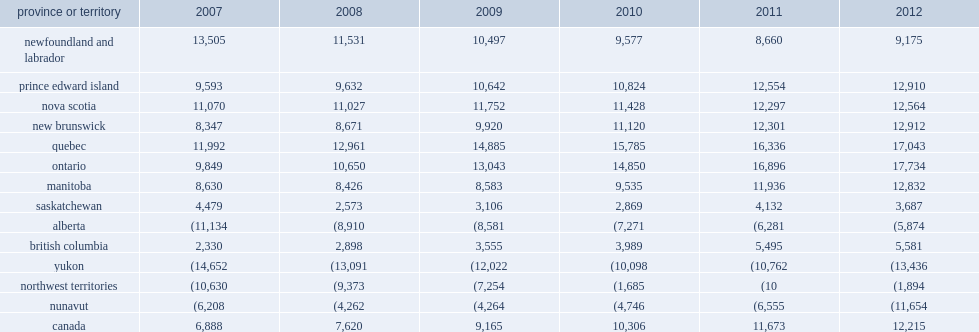In 2007, how many net liability position per capita was recorded by newfoundland? 13505.0. In 2007, how many net liability position per capita was recorded by quebec? 11992.0. In 2008, which place recorded the highest net liability position? Quebec. In 2009, which place recorded the highest net liability position? Quebec. In 2010, which place recorded the highest net liability position? Quebec. In 2007, how many net liability position per capita was recorded by ontario? 9849.0. In 2007, how many net liability position per capita was recorded by ontario? 17734.0. Between 2011 and 2012, how many percentage point of net liability position per capita has increased in ontario? 0.800589. Between 2007 and 2012, how many percentage point of net liability position per capita has increased in prince edward island? 0.345773. Between 2007 and 2012, how many percentage point of net liability position per capita has increased in new brunswick? 0.546903. Between 2007 and 2012, how many percentage point of net liability position per capita has increased in nova scotia? 0.134959. Which place recorded the fifth highest net liability position per capita among provinces and territories in canada in 2012? Manitoba. Between 2007 and 2012, how many percentage point of net liability position per capita has increased in manitoba? 0.486906. Between 2007 and 2012, how many of net liability position per capita has declined in saskatchewan? 792. In 2007, how maany net financial asset position of per capita was recorded in alberta? 11134. In 2012, how many net financial asset position of per capita was recorded in alberta? 5874. In 2012, how many net financial asset position of per capita was recorded in british columbia? 5581.0. Between 2007 and 2012, how many percentage point of net liability position per capita has increased in british columbia? 1.395279. In 2012, how many net financial asset position of per capita was recorded in yukon? 13436.0. In 2012, how many net financial asset position of per capita was recorded in nunavut? 11654.0. 